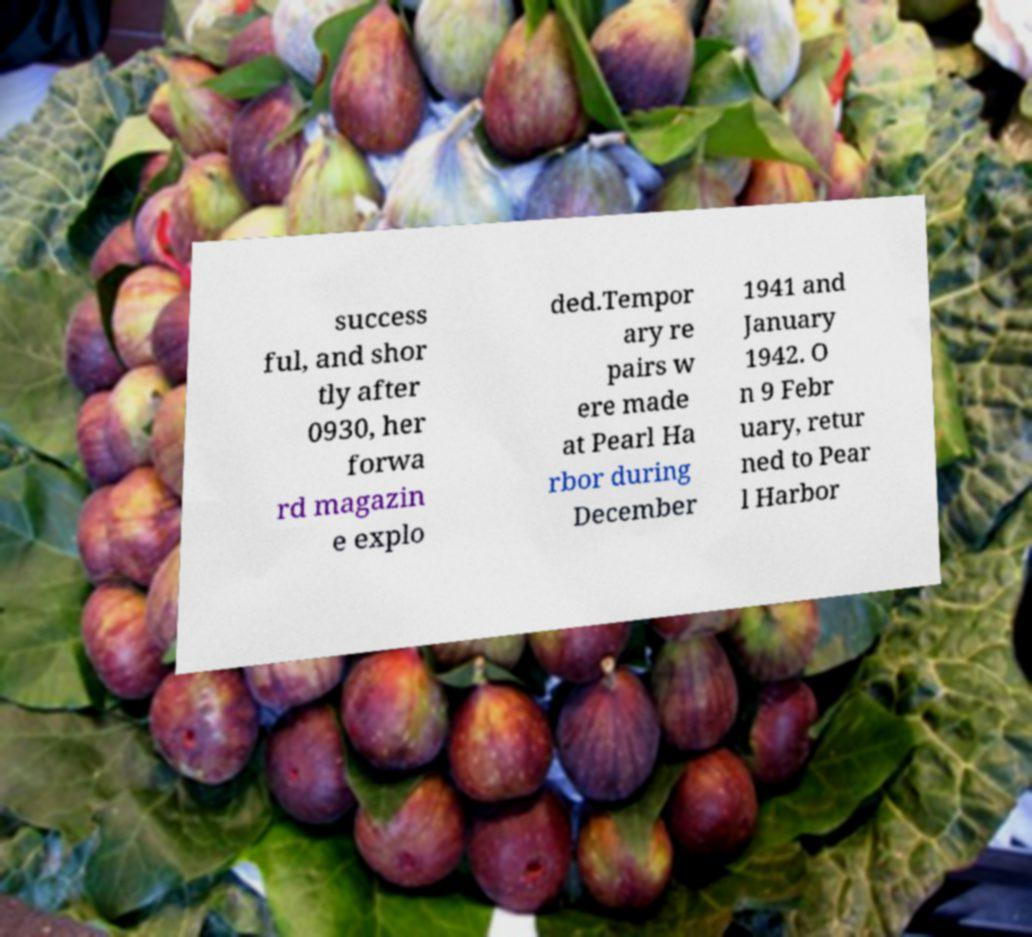Can you accurately transcribe the text from the provided image for me? success ful, and shor tly after 0930, her forwa rd magazin e explo ded.Tempor ary re pairs w ere made at Pearl Ha rbor during December 1941 and January 1942. O n 9 Febr uary, retur ned to Pear l Harbor 